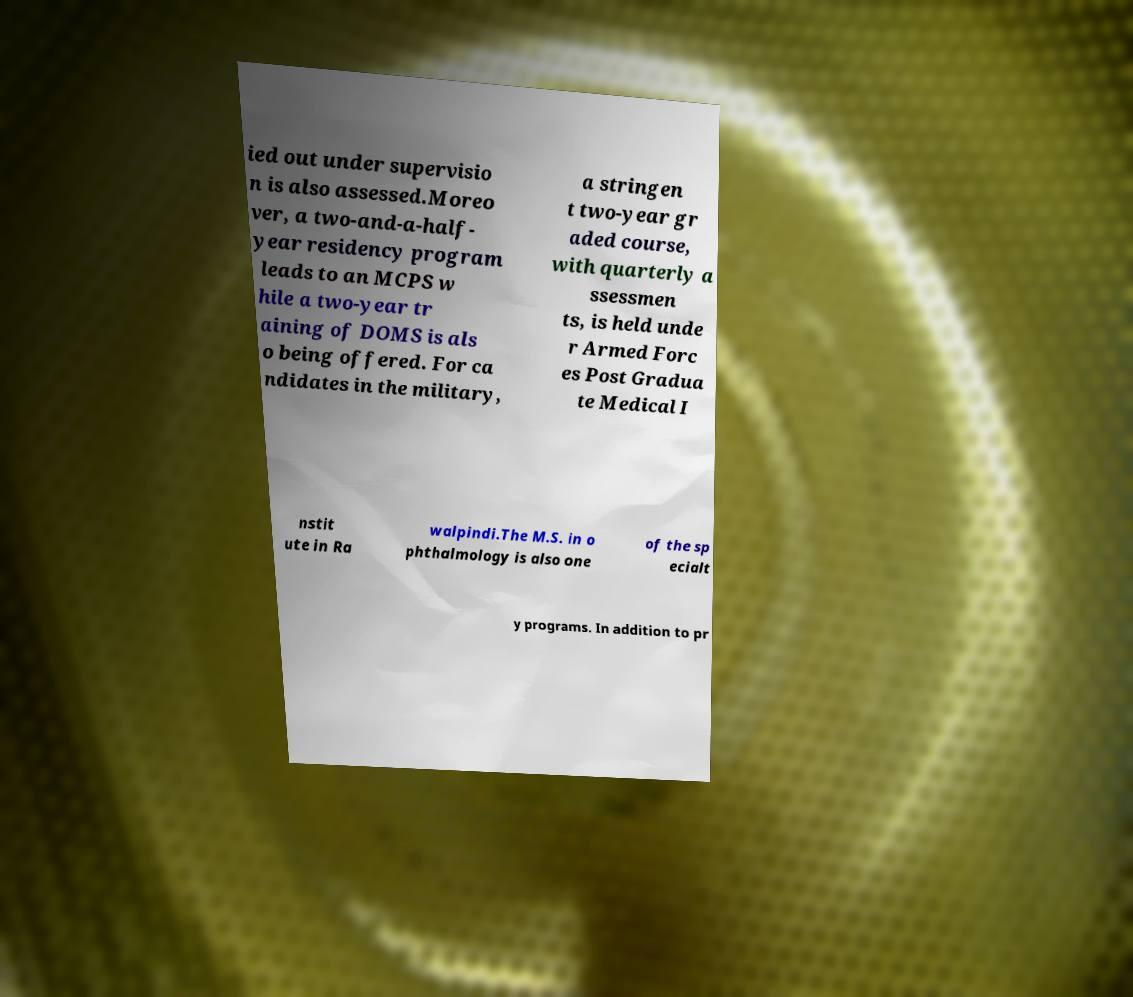There's text embedded in this image that I need extracted. Can you transcribe it verbatim? ied out under supervisio n is also assessed.Moreo ver, a two-and-a-half- year residency program leads to an MCPS w hile a two-year tr aining of DOMS is als o being offered. For ca ndidates in the military, a stringen t two-year gr aded course, with quarterly a ssessmen ts, is held unde r Armed Forc es Post Gradua te Medical I nstit ute in Ra walpindi.The M.S. in o phthalmology is also one of the sp ecialt y programs. In addition to pr 